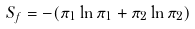Convert formula to latex. <formula><loc_0><loc_0><loc_500><loc_500>S _ { f } = - ( \pi _ { 1 } \ln \pi _ { 1 } + \pi _ { 2 } \ln \pi _ { 2 } )</formula> 